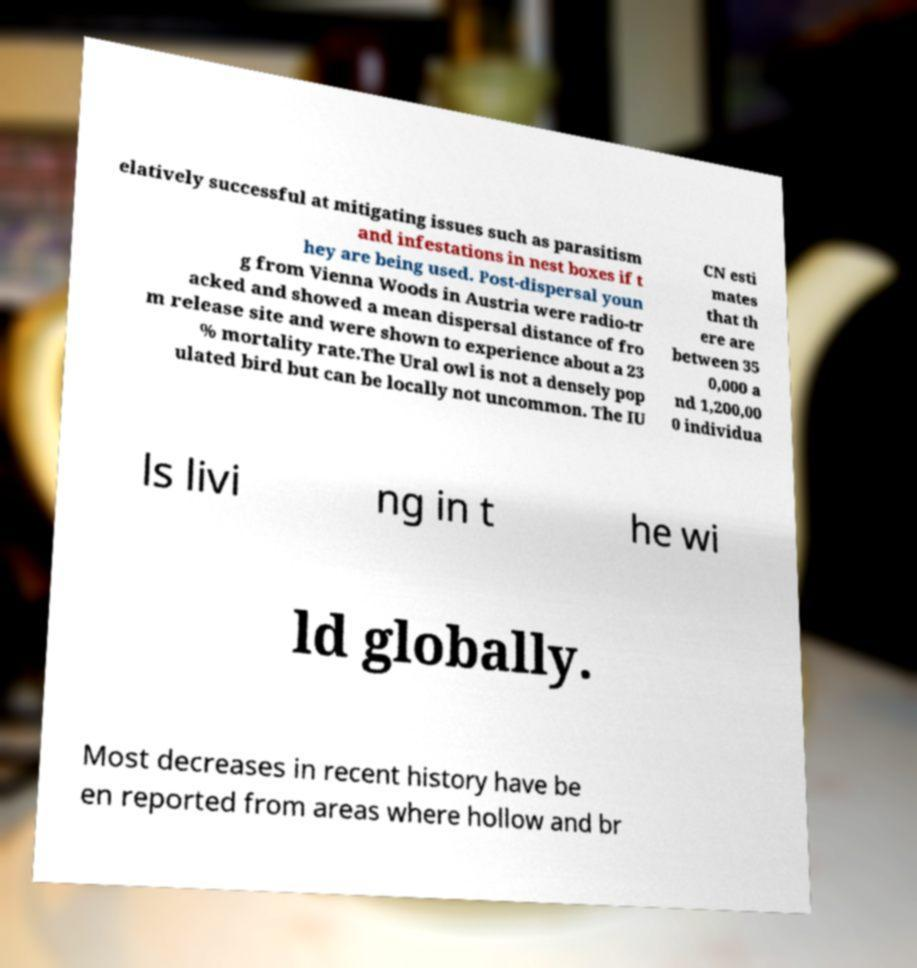There's text embedded in this image that I need extracted. Can you transcribe it verbatim? elatively successful at mitigating issues such as parasitism and infestations in nest boxes if t hey are being used. Post-dispersal youn g from Vienna Woods in Austria were radio-tr acked and showed a mean dispersal distance of fro m release site and were shown to experience about a 23 % mortality rate.The Ural owl is not a densely pop ulated bird but can be locally not uncommon. The IU CN esti mates that th ere are between 35 0,000 a nd 1,200,00 0 individua ls livi ng in t he wi ld globally. Most decreases in recent history have be en reported from areas where hollow and br 